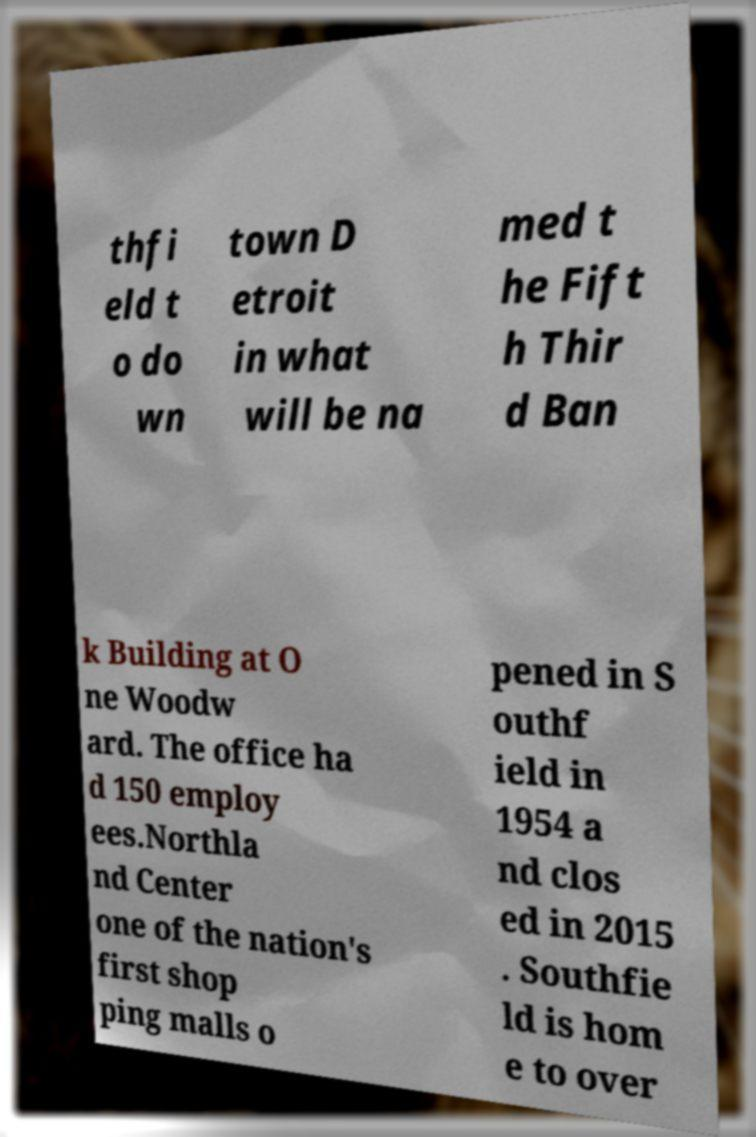Could you extract and type out the text from this image? thfi eld t o do wn town D etroit in what will be na med t he Fift h Thir d Ban k Building at O ne Woodw ard. The office ha d 150 employ ees.Northla nd Center one of the nation's first shop ping malls o pened in S outhf ield in 1954 a nd clos ed in 2015 . Southfie ld is hom e to over 